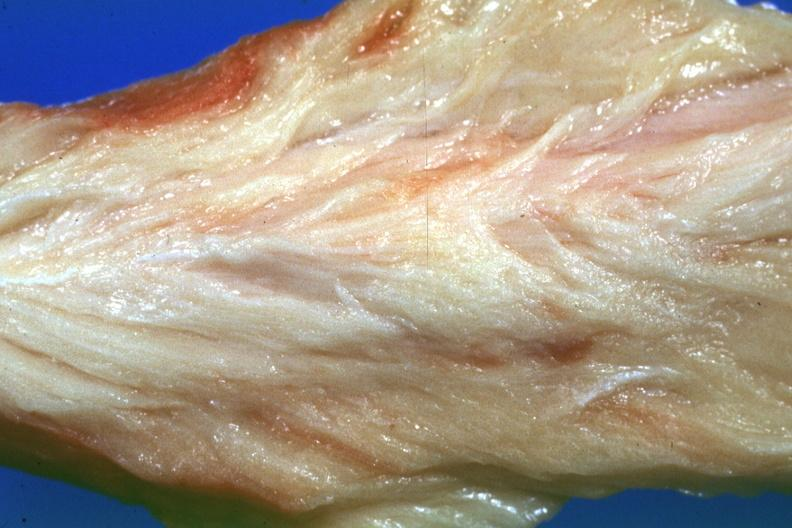s soft tissue present?
Answer the question using a single word or phrase. Yes 